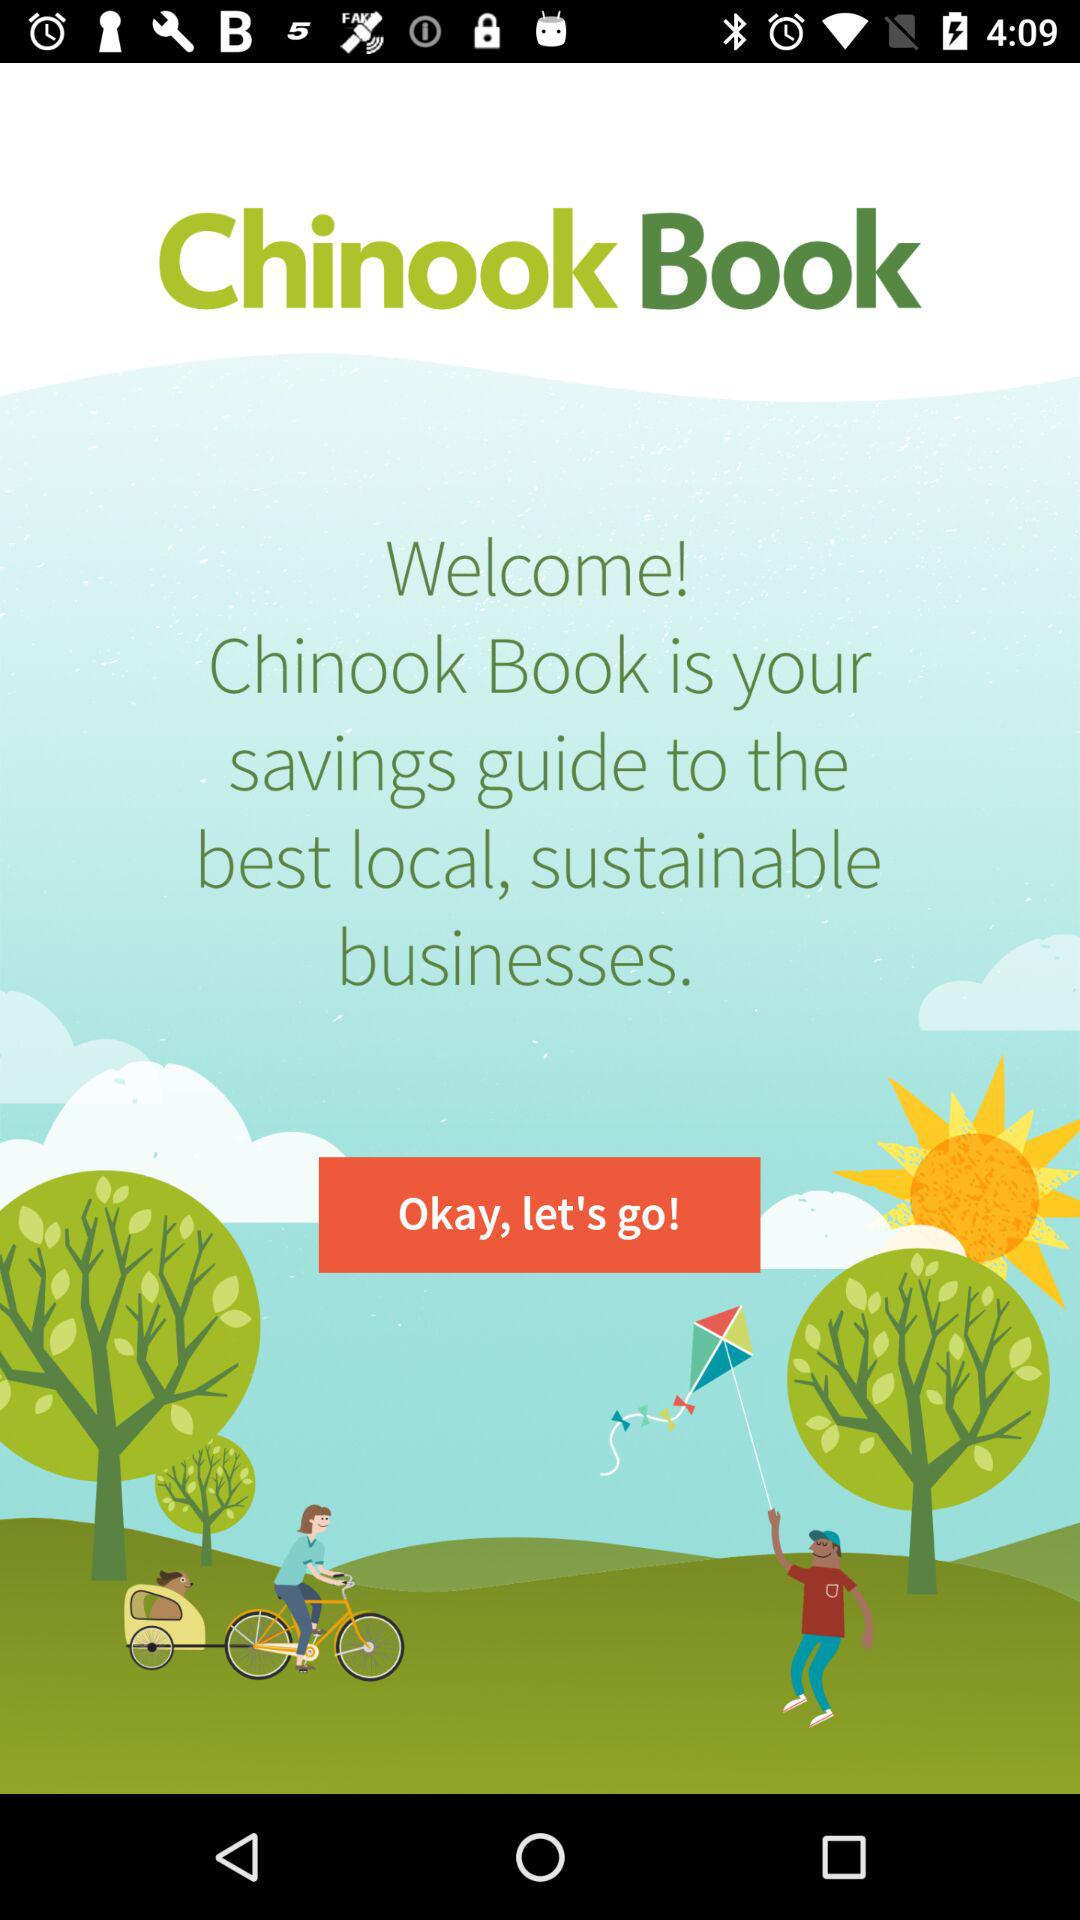What is the name of the application? The name of the application is "Chinook Book". 